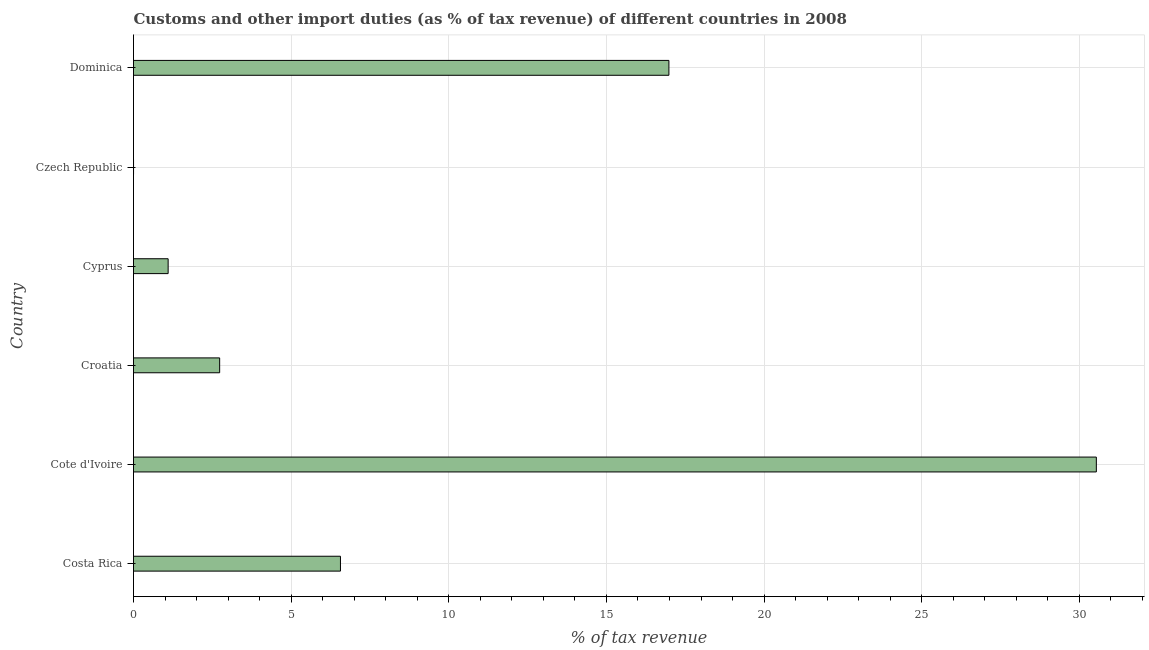Does the graph contain any zero values?
Offer a very short reply. No. What is the title of the graph?
Provide a succinct answer. Customs and other import duties (as % of tax revenue) of different countries in 2008. What is the label or title of the X-axis?
Give a very brief answer. % of tax revenue. What is the customs and other import duties in Cote d'Ivoire?
Provide a succinct answer. 30.54. Across all countries, what is the maximum customs and other import duties?
Offer a terse response. 30.54. Across all countries, what is the minimum customs and other import duties?
Ensure brevity in your answer.  0. In which country was the customs and other import duties maximum?
Keep it short and to the point. Cote d'Ivoire. In which country was the customs and other import duties minimum?
Your response must be concise. Czech Republic. What is the sum of the customs and other import duties?
Make the answer very short. 57.92. What is the difference between the customs and other import duties in Costa Rica and Czech Republic?
Your response must be concise. 6.56. What is the average customs and other import duties per country?
Your answer should be very brief. 9.65. What is the median customs and other import duties?
Keep it short and to the point. 4.65. What is the ratio of the customs and other import duties in Costa Rica to that in Cote d'Ivoire?
Your answer should be very brief. 0.21. Is the customs and other import duties in Croatia less than that in Czech Republic?
Keep it short and to the point. No. What is the difference between the highest and the second highest customs and other import duties?
Ensure brevity in your answer.  13.56. What is the difference between the highest and the lowest customs and other import duties?
Keep it short and to the point. 30.54. How many bars are there?
Offer a very short reply. 6. How many countries are there in the graph?
Your answer should be very brief. 6. What is the difference between two consecutive major ticks on the X-axis?
Your answer should be very brief. 5. Are the values on the major ticks of X-axis written in scientific E-notation?
Your response must be concise. No. What is the % of tax revenue of Costa Rica?
Give a very brief answer. 6.56. What is the % of tax revenue of Cote d'Ivoire?
Offer a terse response. 30.54. What is the % of tax revenue in Croatia?
Provide a short and direct response. 2.73. What is the % of tax revenue in Cyprus?
Offer a terse response. 1.1. What is the % of tax revenue of Czech Republic?
Ensure brevity in your answer.  0. What is the % of tax revenue in Dominica?
Give a very brief answer. 16.98. What is the difference between the % of tax revenue in Costa Rica and Cote d'Ivoire?
Offer a terse response. -23.98. What is the difference between the % of tax revenue in Costa Rica and Croatia?
Provide a succinct answer. 3.83. What is the difference between the % of tax revenue in Costa Rica and Cyprus?
Ensure brevity in your answer.  5.47. What is the difference between the % of tax revenue in Costa Rica and Czech Republic?
Provide a short and direct response. 6.56. What is the difference between the % of tax revenue in Costa Rica and Dominica?
Offer a terse response. -10.42. What is the difference between the % of tax revenue in Cote d'Ivoire and Croatia?
Your answer should be very brief. 27.81. What is the difference between the % of tax revenue in Cote d'Ivoire and Cyprus?
Your answer should be very brief. 29.44. What is the difference between the % of tax revenue in Cote d'Ivoire and Czech Republic?
Provide a succinct answer. 30.54. What is the difference between the % of tax revenue in Cote d'Ivoire and Dominica?
Offer a terse response. 13.56. What is the difference between the % of tax revenue in Croatia and Cyprus?
Provide a succinct answer. 1.63. What is the difference between the % of tax revenue in Croatia and Czech Republic?
Your response must be concise. 2.73. What is the difference between the % of tax revenue in Croatia and Dominica?
Keep it short and to the point. -14.25. What is the difference between the % of tax revenue in Cyprus and Czech Republic?
Provide a short and direct response. 1.1. What is the difference between the % of tax revenue in Cyprus and Dominica?
Your response must be concise. -15.88. What is the difference between the % of tax revenue in Czech Republic and Dominica?
Make the answer very short. -16.98. What is the ratio of the % of tax revenue in Costa Rica to that in Cote d'Ivoire?
Keep it short and to the point. 0.21. What is the ratio of the % of tax revenue in Costa Rica to that in Croatia?
Ensure brevity in your answer.  2.4. What is the ratio of the % of tax revenue in Costa Rica to that in Cyprus?
Offer a terse response. 5.97. What is the ratio of the % of tax revenue in Costa Rica to that in Czech Republic?
Provide a short and direct response. 4487.65. What is the ratio of the % of tax revenue in Costa Rica to that in Dominica?
Offer a terse response. 0.39. What is the ratio of the % of tax revenue in Cote d'Ivoire to that in Croatia?
Make the answer very short. 11.18. What is the ratio of the % of tax revenue in Cote d'Ivoire to that in Cyprus?
Ensure brevity in your answer.  27.8. What is the ratio of the % of tax revenue in Cote d'Ivoire to that in Czech Republic?
Provide a succinct answer. 2.09e+04. What is the ratio of the % of tax revenue in Cote d'Ivoire to that in Dominica?
Make the answer very short. 1.8. What is the ratio of the % of tax revenue in Croatia to that in Cyprus?
Your answer should be compact. 2.49. What is the ratio of the % of tax revenue in Croatia to that in Czech Republic?
Provide a succinct answer. 1868.18. What is the ratio of the % of tax revenue in Croatia to that in Dominica?
Your response must be concise. 0.16. What is the ratio of the % of tax revenue in Cyprus to that in Czech Republic?
Provide a short and direct response. 751.06. What is the ratio of the % of tax revenue in Cyprus to that in Dominica?
Make the answer very short. 0.07. What is the ratio of the % of tax revenue in Czech Republic to that in Dominica?
Provide a succinct answer. 0. 